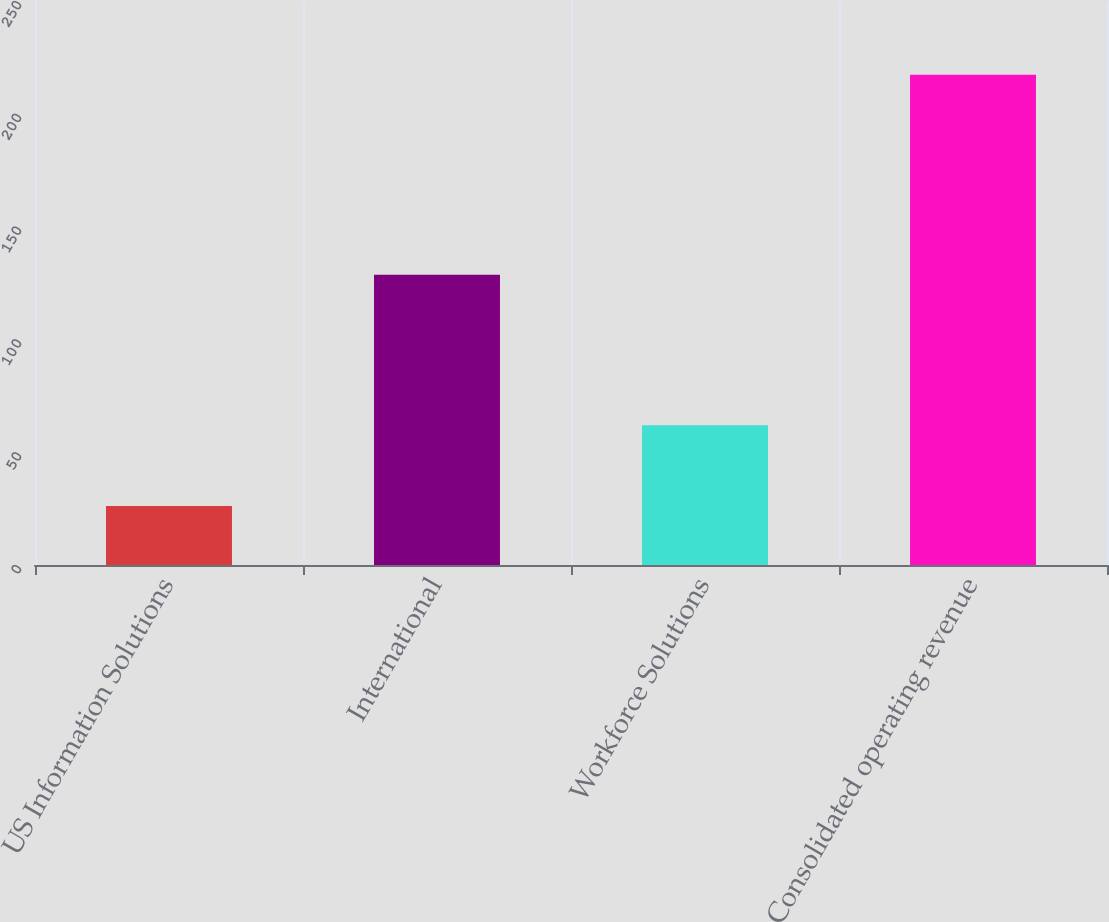Convert chart. <chart><loc_0><loc_0><loc_500><loc_500><bar_chart><fcel>US Information Solutions<fcel>International<fcel>Workforce Solutions<fcel>Consolidated operating revenue<nl><fcel>26.2<fcel>128.7<fcel>62<fcel>217.3<nl></chart> 